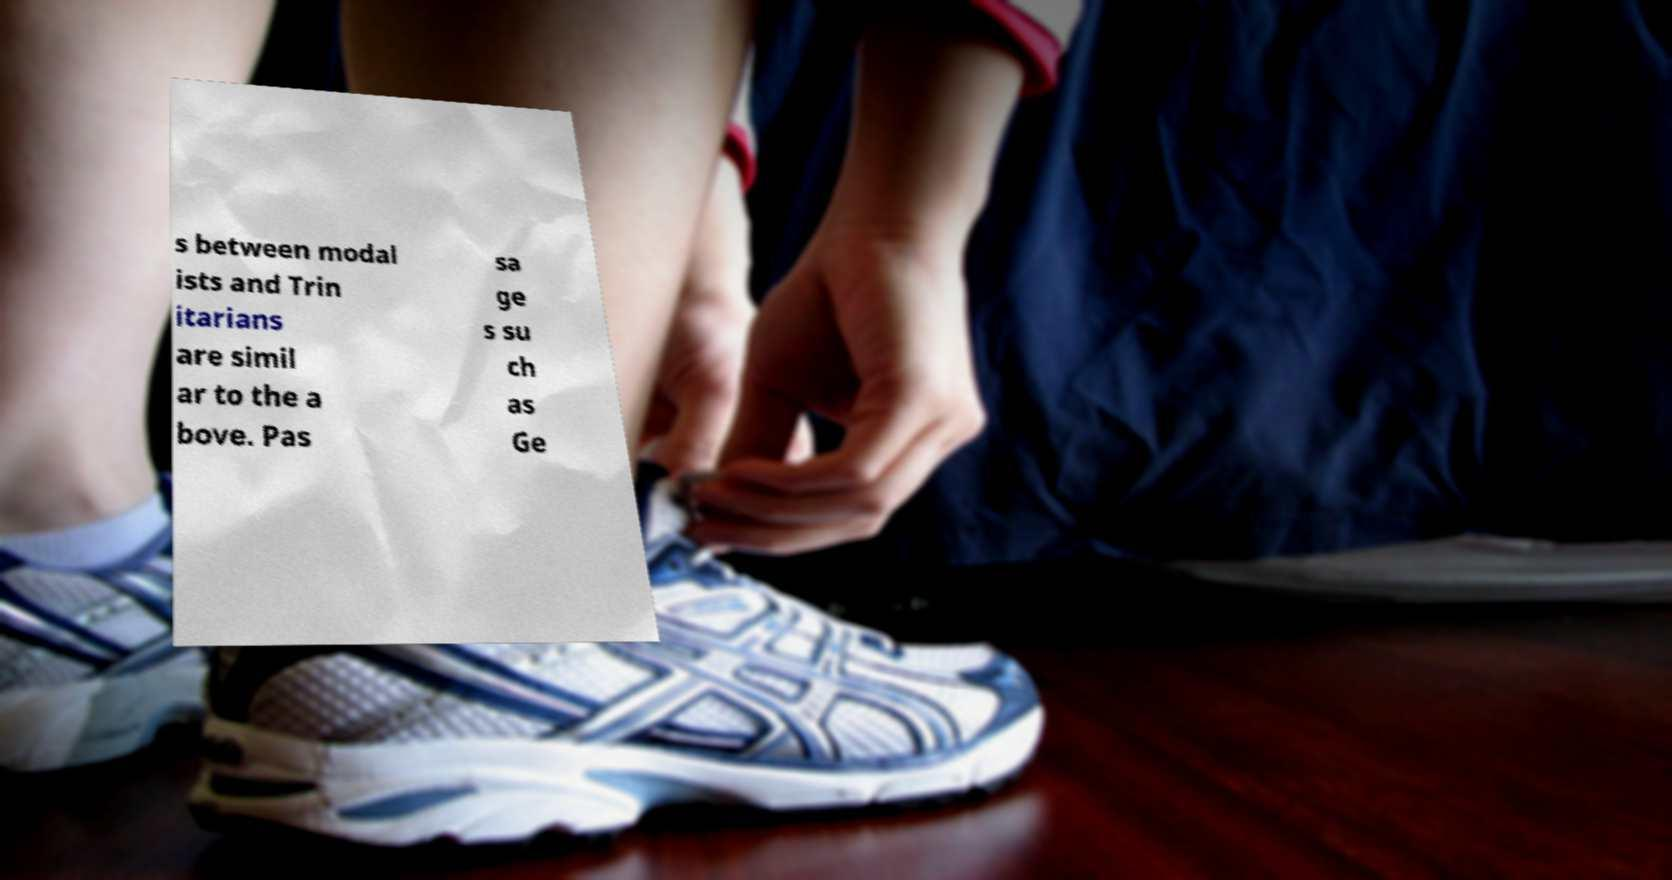Can you read and provide the text displayed in the image?This photo seems to have some interesting text. Can you extract and type it out for me? s between modal ists and Trin itarians are simil ar to the a bove. Pas sa ge s su ch as Ge 